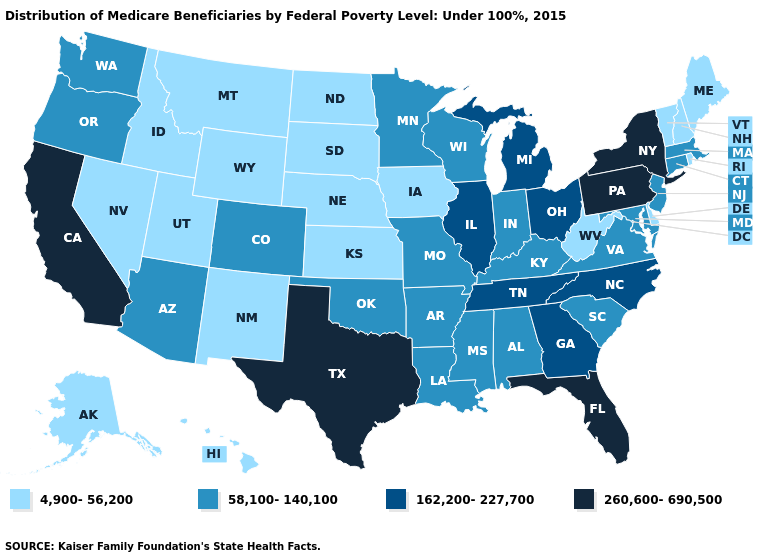Is the legend a continuous bar?
Quick response, please. No. Is the legend a continuous bar?
Answer briefly. No. What is the value of Michigan?
Quick response, please. 162,200-227,700. Name the states that have a value in the range 58,100-140,100?
Concise answer only. Alabama, Arizona, Arkansas, Colorado, Connecticut, Indiana, Kentucky, Louisiana, Maryland, Massachusetts, Minnesota, Mississippi, Missouri, New Jersey, Oklahoma, Oregon, South Carolina, Virginia, Washington, Wisconsin. What is the value of Colorado?
Write a very short answer. 58,100-140,100. Name the states that have a value in the range 162,200-227,700?
Answer briefly. Georgia, Illinois, Michigan, North Carolina, Ohio, Tennessee. What is the highest value in the Northeast ?
Write a very short answer. 260,600-690,500. Name the states that have a value in the range 4,900-56,200?
Be succinct. Alaska, Delaware, Hawaii, Idaho, Iowa, Kansas, Maine, Montana, Nebraska, Nevada, New Hampshire, New Mexico, North Dakota, Rhode Island, South Dakota, Utah, Vermont, West Virginia, Wyoming. What is the value of Ohio?
Keep it brief. 162,200-227,700. What is the value of New Jersey?
Concise answer only. 58,100-140,100. What is the value of Tennessee?
Be succinct. 162,200-227,700. Does Georgia have a lower value than New York?
Give a very brief answer. Yes. What is the value of North Dakota?
Quick response, please. 4,900-56,200. What is the value of Nevada?
Write a very short answer. 4,900-56,200. Which states have the highest value in the USA?
Give a very brief answer. California, Florida, New York, Pennsylvania, Texas. 